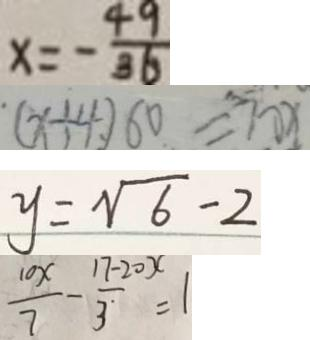<formula> <loc_0><loc_0><loc_500><loc_500>x = - \frac { 4 9 } { 3 6 } 
 ( x + 4 ) 6 0 = 7 0 x 
 y = \sqrt { 6 } - 2 
 \frac { 1 0 x } { 7 } - \frac { 1 7 - 2 0 x } { 3 } = 1</formula> 